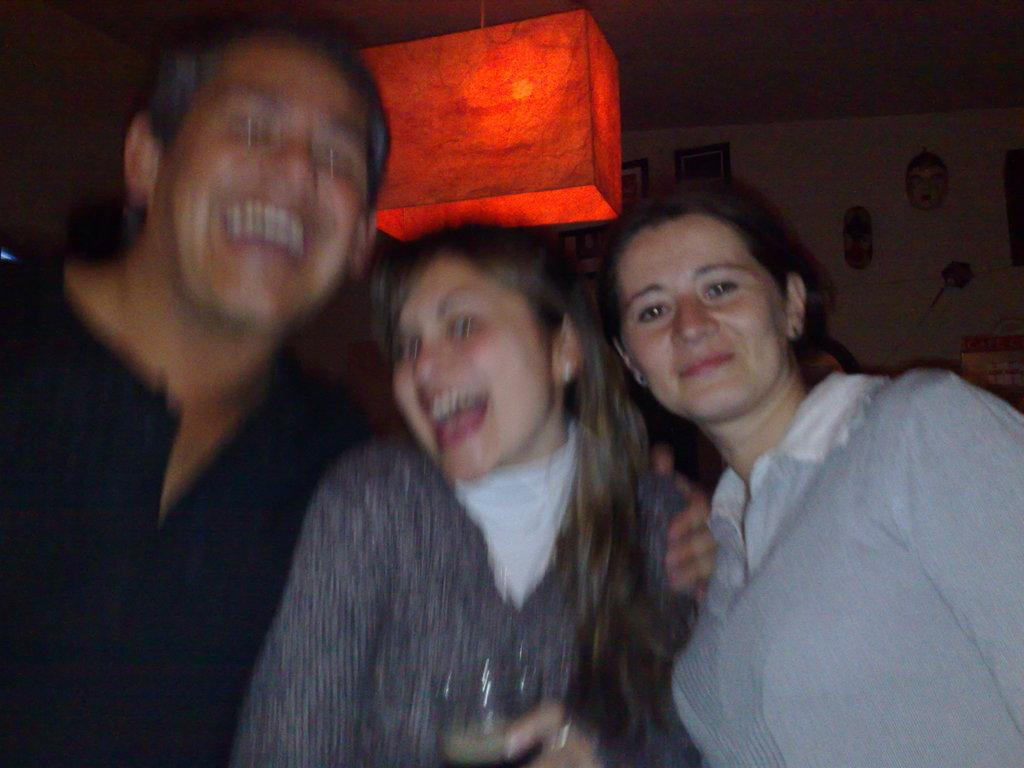How many people are present in the image? There are three persons in the image. What is the middle person holding? The middle person is holding a glass. What can be seen in the background of the image? There is a light and a wall with photo frames in the background. What else is visible on the wall in the background? There are other items visible on the wall in the background. What type of jam is being served at the party in the image? There is no party or jam present in the image. Can you describe the bushes visible in the image? There are no bushes visible in the image. 